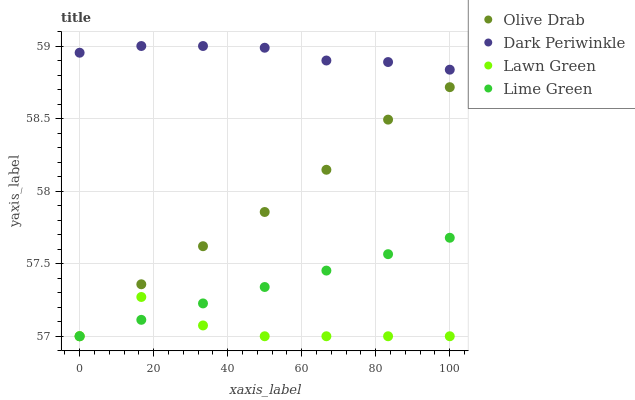Does Lawn Green have the minimum area under the curve?
Answer yes or no. Yes. Does Dark Periwinkle have the maximum area under the curve?
Answer yes or no. Yes. Does Lime Green have the minimum area under the curve?
Answer yes or no. No. Does Lime Green have the maximum area under the curve?
Answer yes or no. No. Is Lime Green the smoothest?
Answer yes or no. Yes. Is Lawn Green the roughest?
Answer yes or no. Yes. Is Dark Periwinkle the smoothest?
Answer yes or no. No. Is Dark Periwinkle the roughest?
Answer yes or no. No. Does Lawn Green have the lowest value?
Answer yes or no. Yes. Does Dark Periwinkle have the lowest value?
Answer yes or no. No. Does Dark Periwinkle have the highest value?
Answer yes or no. Yes. Does Lime Green have the highest value?
Answer yes or no. No. Is Olive Drab less than Dark Periwinkle?
Answer yes or no. Yes. Is Dark Periwinkle greater than Lawn Green?
Answer yes or no. Yes. Does Lime Green intersect Olive Drab?
Answer yes or no. Yes. Is Lime Green less than Olive Drab?
Answer yes or no. No. Is Lime Green greater than Olive Drab?
Answer yes or no. No. Does Olive Drab intersect Dark Periwinkle?
Answer yes or no. No. 